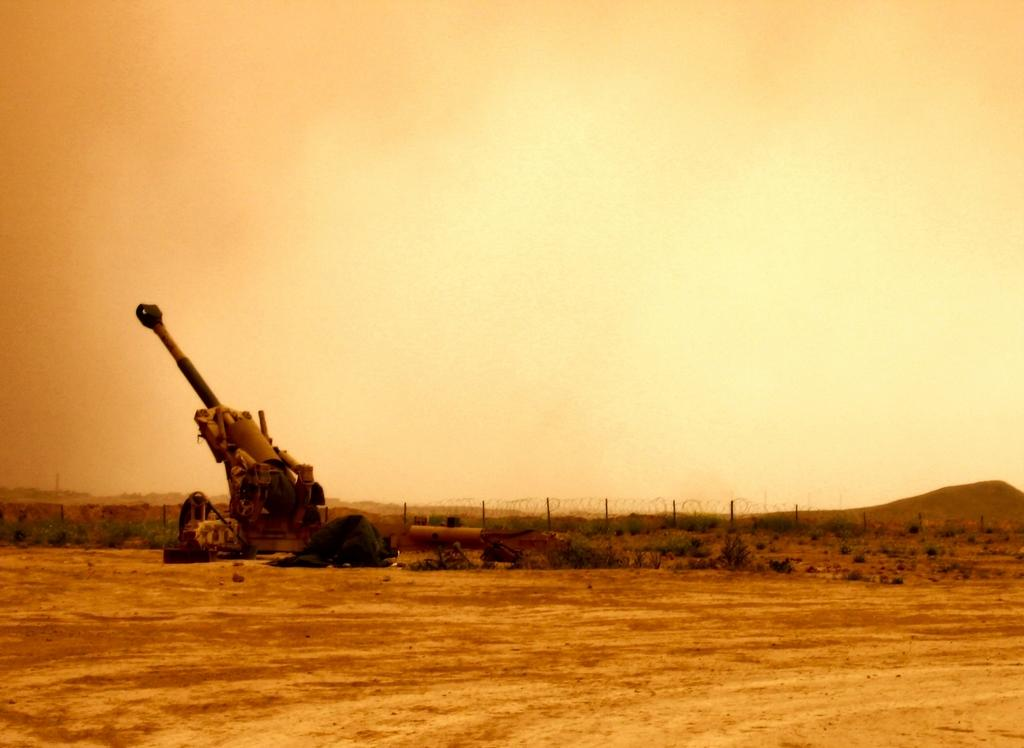What type of surface is visible in the image? There is a ground surface in the image. What can be found on the ground surface? There is an army weapon on the ground surface. What type of barrier is present in the image? There is fencing visible in the image. What can be seen in the distance in the image? There are hills in the background of the image. What is visible above the hills in the image? The sky is visible in the background of the image. What type of magic is being performed with the net in the image? There is no net or magic present in the image; it features a ground surface, an army weapon, fencing, hills, and the sky. 